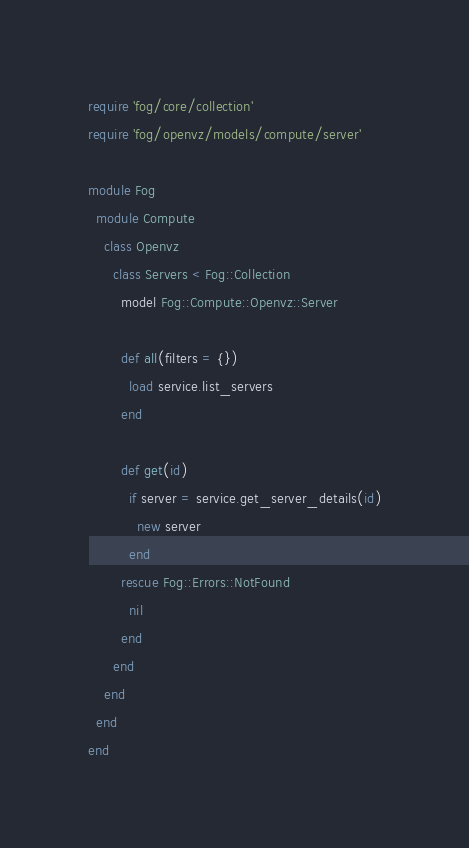<code> <loc_0><loc_0><loc_500><loc_500><_Ruby_>require 'fog/core/collection'
require 'fog/openvz/models/compute/server'

module Fog
  module Compute
    class Openvz
      class Servers < Fog::Collection
        model Fog::Compute::Openvz::Server

        def all(filters = {})
          load service.list_servers
        end

        def get(id)
          if server = service.get_server_details(id)
            new server
          end
        rescue Fog::Errors::NotFound
          nil
        end
      end
    end
  end
end
</code> 